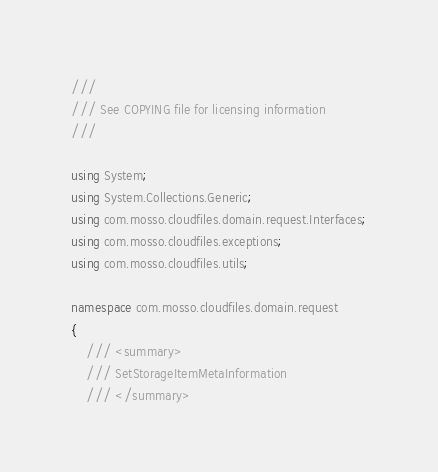Convert code to text. <code><loc_0><loc_0><loc_500><loc_500><_C#_>///
/// See COPYING file for licensing information
///

using System;
using System.Collections.Generic;
using com.mosso.cloudfiles.domain.request.Interfaces;
using com.mosso.cloudfiles.exceptions;
using com.mosso.cloudfiles.utils;

namespace com.mosso.cloudfiles.domain.request
{
    /// <summary>
    /// SetStorageItemMetaInformation
    /// </summary></code> 